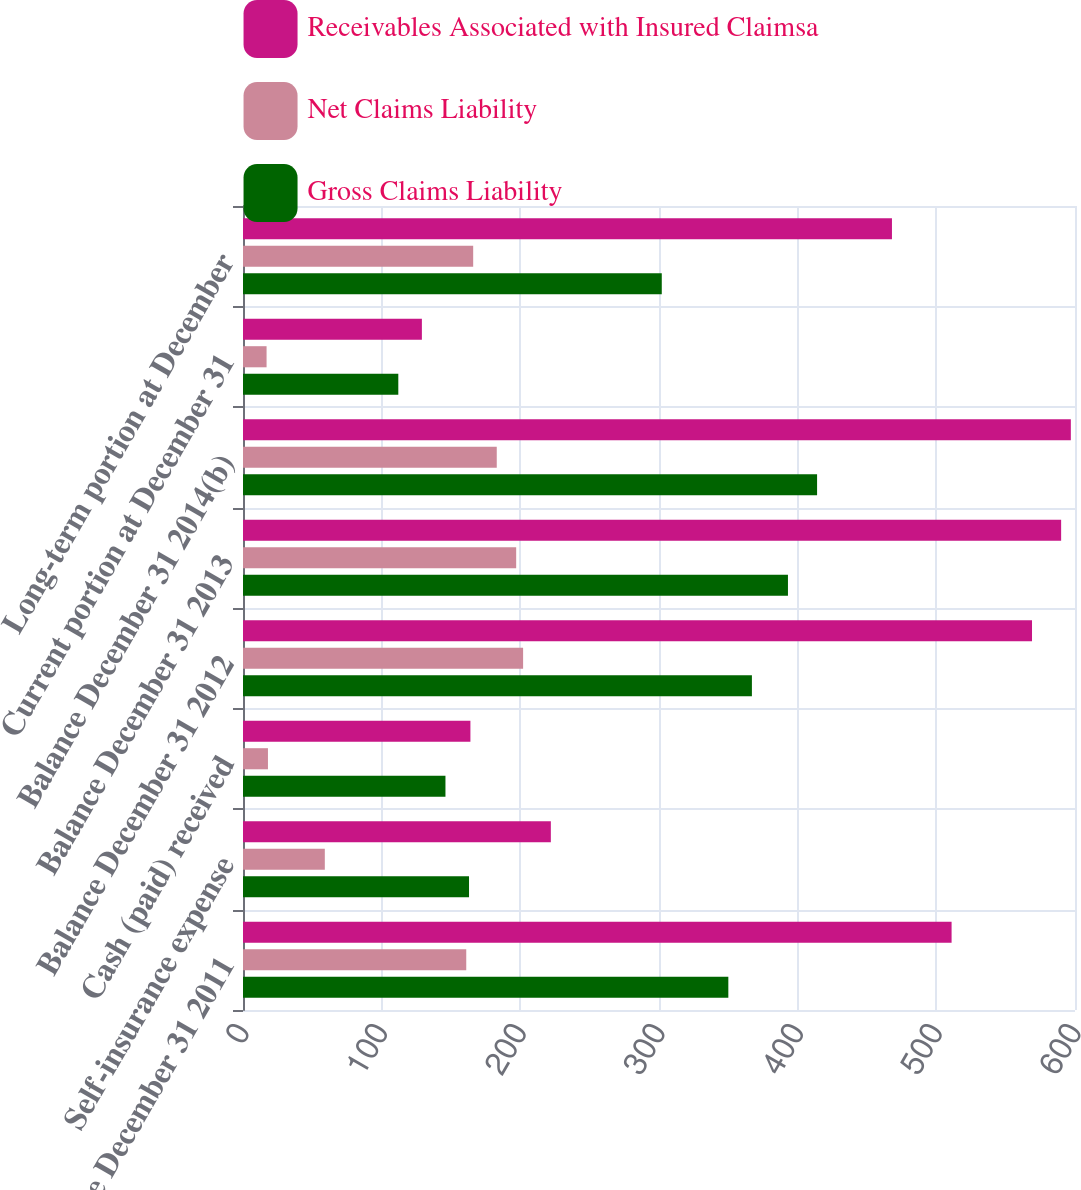Convert chart to OTSL. <chart><loc_0><loc_0><loc_500><loc_500><stacked_bar_chart><ecel><fcel>Balance December 31 2011<fcel>Self-insurance expense<fcel>Cash (paid) received<fcel>Balance December 31 2012<fcel>Balance December 31 2013<fcel>Balance December 31 2014(b)<fcel>Current portion at December 31<fcel>Long-term portion at December<nl><fcel>Receivables Associated with Insured Claimsa<fcel>511<fcel>222<fcel>164<fcel>569<fcel>590<fcel>597<fcel>129<fcel>468<nl><fcel>Net Claims Liability<fcel>161<fcel>59<fcel>18<fcel>202<fcel>197<fcel>183<fcel>17<fcel>166<nl><fcel>Gross Claims Liability<fcel>350<fcel>163<fcel>146<fcel>367<fcel>393<fcel>414<fcel>112<fcel>302<nl></chart> 